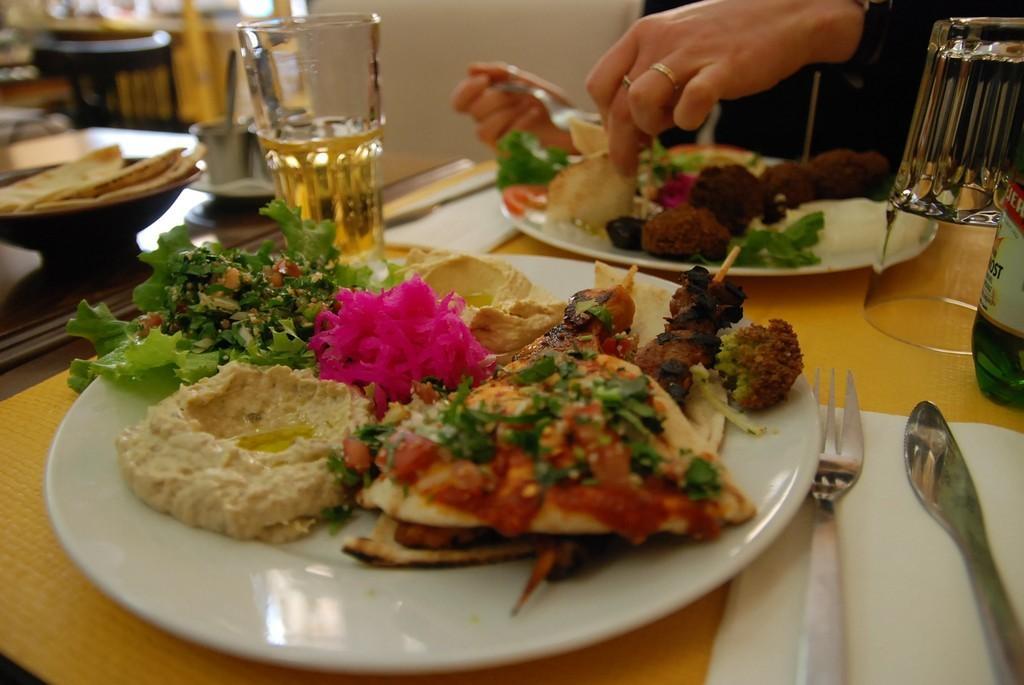Could you give a brief overview of what you see in this image? In this image there is a table, on that table there are plants, in that place there is food item and there are glasses, spoons and a man is eating food. 